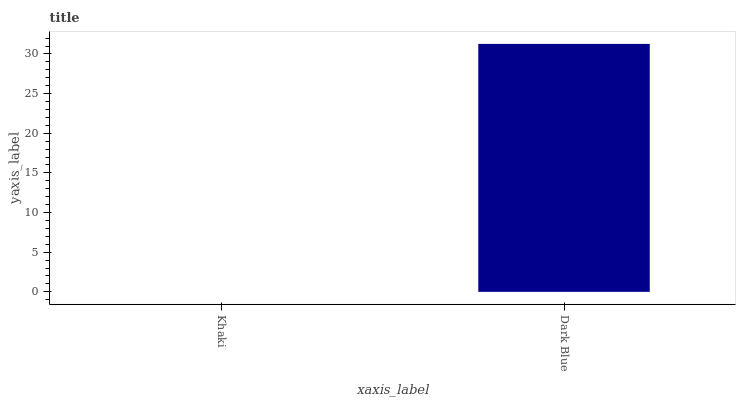Is Dark Blue the minimum?
Answer yes or no. No. Is Dark Blue greater than Khaki?
Answer yes or no. Yes. Is Khaki less than Dark Blue?
Answer yes or no. Yes. Is Khaki greater than Dark Blue?
Answer yes or no. No. Is Dark Blue less than Khaki?
Answer yes or no. No. Is Dark Blue the high median?
Answer yes or no. Yes. Is Khaki the low median?
Answer yes or no. Yes. Is Khaki the high median?
Answer yes or no. No. Is Dark Blue the low median?
Answer yes or no. No. 